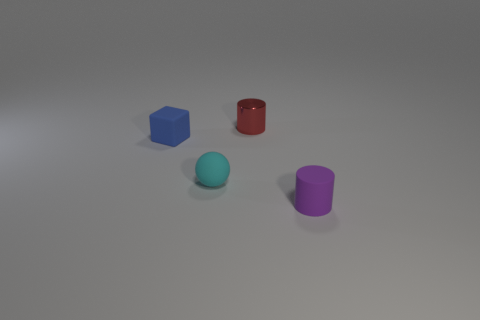Is there a purple matte cylinder that is behind the tiny cylinder that is in front of the rubber object on the left side of the cyan ball?
Make the answer very short. No. There is a object on the right side of the red metallic thing; is it the same shape as the small red object behind the small cyan matte ball?
Your response must be concise. Yes. There is a cube that is made of the same material as the sphere; what color is it?
Offer a very short reply. Blue. Are there fewer tiny cyan things left of the tiny matte sphere than green cylinders?
Ensure brevity in your answer.  No. There is a object that is in front of the ball that is in front of the small cylinder that is behind the tiny purple matte cylinder; what size is it?
Give a very brief answer. Small. Does the thing in front of the cyan matte ball have the same material as the cyan sphere?
Your answer should be very brief. Yes. Is there anything else that has the same shape as the red shiny thing?
Give a very brief answer. Yes. What number of things are large gray matte cylinders or tiny cylinders?
Make the answer very short. 2. The other thing that is the same shape as the metal thing is what size?
Your response must be concise. Small. Are there any other things that are the same size as the blue rubber thing?
Your answer should be very brief. Yes. 